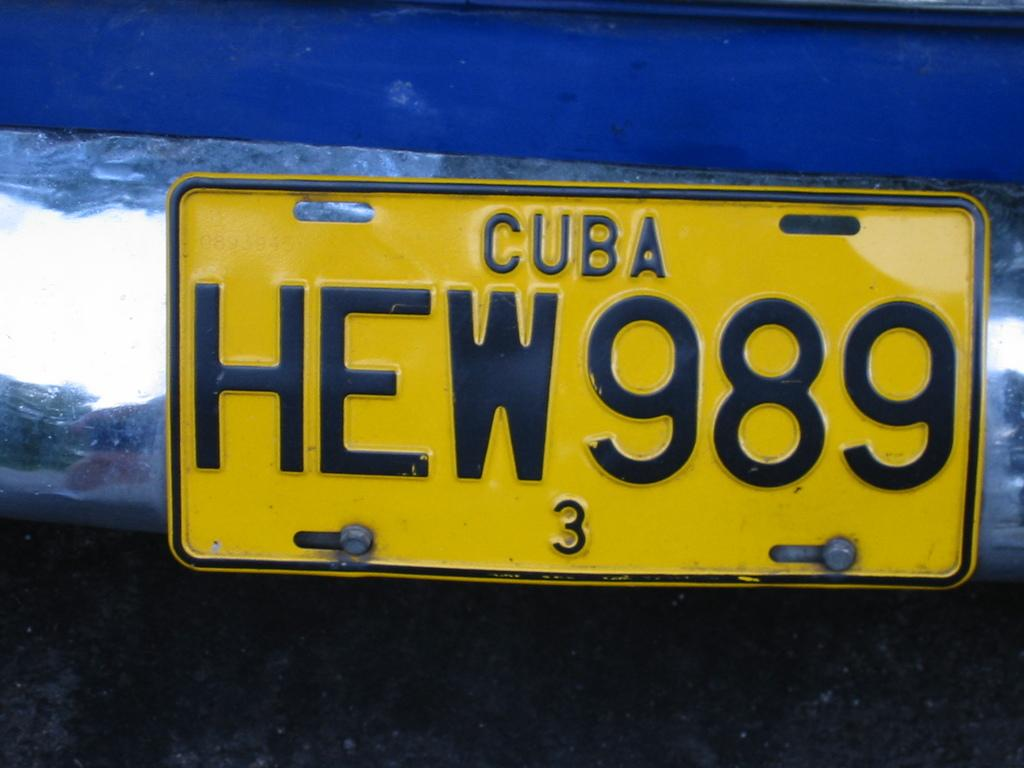<image>
Relay a brief, clear account of the picture shown. A Cuban license plate reads HEW 989 and has a 3 on the bottom. 